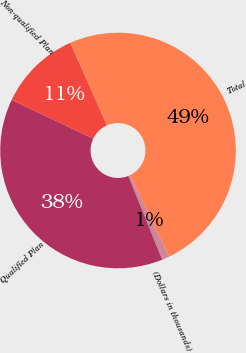Convert chart to OTSL. <chart><loc_0><loc_0><loc_500><loc_500><pie_chart><fcel>(Dollars in thousands)<fcel>Qualified Plan<fcel>Non-qualified Plan<fcel>Total<nl><fcel>1.04%<fcel>38.18%<fcel>11.3%<fcel>49.48%<nl></chart> 